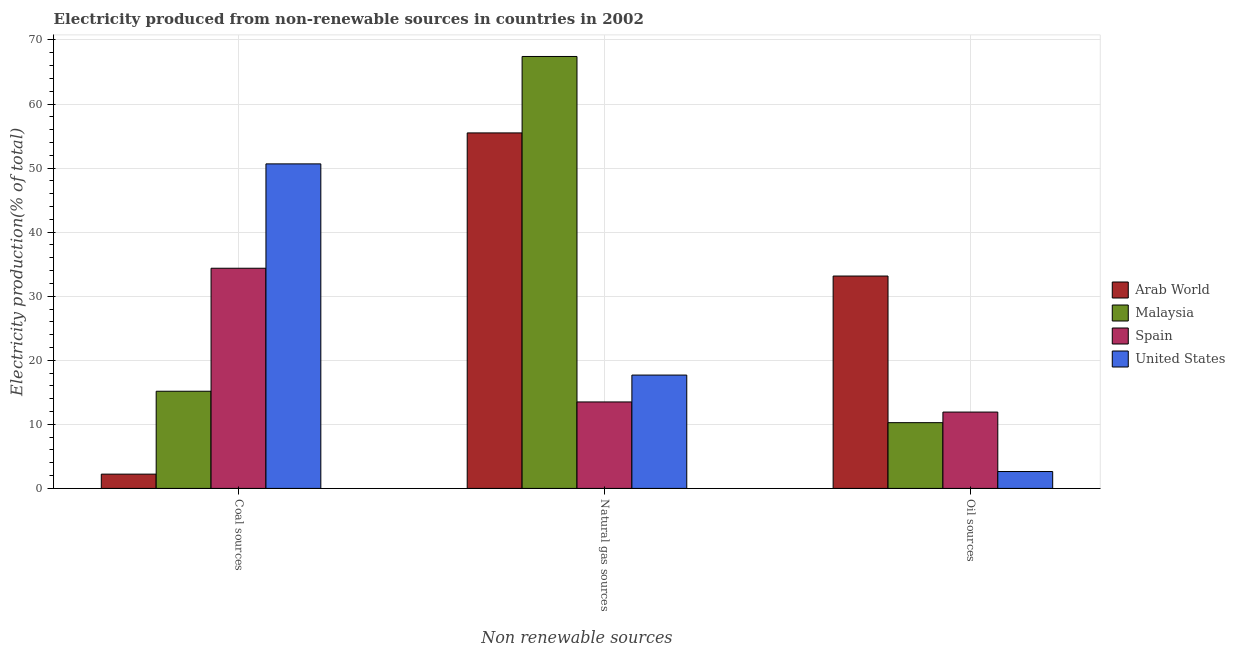How many groups of bars are there?
Your response must be concise. 3. Are the number of bars per tick equal to the number of legend labels?
Give a very brief answer. Yes. Are the number of bars on each tick of the X-axis equal?
Your answer should be compact. Yes. How many bars are there on the 2nd tick from the right?
Your response must be concise. 4. What is the label of the 3rd group of bars from the left?
Your response must be concise. Oil sources. What is the percentage of electricity produced by natural gas in Arab World?
Your response must be concise. 55.49. Across all countries, what is the maximum percentage of electricity produced by oil sources?
Your answer should be compact. 33.15. Across all countries, what is the minimum percentage of electricity produced by natural gas?
Ensure brevity in your answer.  13.5. In which country was the percentage of electricity produced by natural gas maximum?
Give a very brief answer. Malaysia. In which country was the percentage of electricity produced by coal minimum?
Offer a terse response. Arab World. What is the total percentage of electricity produced by oil sources in the graph?
Your response must be concise. 57.97. What is the difference between the percentage of electricity produced by coal in Spain and that in Arab World?
Give a very brief answer. 32.14. What is the difference between the percentage of electricity produced by oil sources in United States and the percentage of electricity produced by natural gas in Spain?
Make the answer very short. -10.86. What is the average percentage of electricity produced by oil sources per country?
Your answer should be compact. 14.49. What is the difference between the percentage of electricity produced by coal and percentage of electricity produced by natural gas in Spain?
Offer a very short reply. 20.87. In how many countries, is the percentage of electricity produced by oil sources greater than 16 %?
Your answer should be very brief. 1. What is the ratio of the percentage of electricity produced by natural gas in Spain to that in United States?
Your response must be concise. 0.76. Is the percentage of electricity produced by coal in Arab World less than that in Spain?
Provide a succinct answer. Yes. What is the difference between the highest and the second highest percentage of electricity produced by coal?
Your response must be concise. 16.29. What is the difference between the highest and the lowest percentage of electricity produced by coal?
Ensure brevity in your answer.  48.43. What does the 4th bar from the right in Oil sources represents?
Offer a terse response. Arab World. Is it the case that in every country, the sum of the percentage of electricity produced by coal and percentage of electricity produced by natural gas is greater than the percentage of electricity produced by oil sources?
Offer a very short reply. Yes. Are all the bars in the graph horizontal?
Provide a succinct answer. No. What is the difference between two consecutive major ticks on the Y-axis?
Your answer should be very brief. 10. Does the graph contain any zero values?
Your answer should be compact. No. Does the graph contain grids?
Offer a very short reply. Yes. How many legend labels are there?
Offer a terse response. 4. How are the legend labels stacked?
Your answer should be compact. Vertical. What is the title of the graph?
Ensure brevity in your answer.  Electricity produced from non-renewable sources in countries in 2002. Does "Swaziland" appear as one of the legend labels in the graph?
Make the answer very short. No. What is the label or title of the X-axis?
Your answer should be compact. Non renewable sources. What is the label or title of the Y-axis?
Give a very brief answer. Electricity production(% of total). What is the Electricity production(% of total) in Arab World in Coal sources?
Your answer should be very brief. 2.23. What is the Electricity production(% of total) of Malaysia in Coal sources?
Provide a short and direct response. 15.17. What is the Electricity production(% of total) in Spain in Coal sources?
Your response must be concise. 34.37. What is the Electricity production(% of total) of United States in Coal sources?
Give a very brief answer. 50.66. What is the Electricity production(% of total) of Arab World in Natural gas sources?
Ensure brevity in your answer.  55.49. What is the Electricity production(% of total) in Malaysia in Natural gas sources?
Your answer should be compact. 67.42. What is the Electricity production(% of total) in Spain in Natural gas sources?
Keep it short and to the point. 13.5. What is the Electricity production(% of total) of United States in Natural gas sources?
Ensure brevity in your answer.  17.69. What is the Electricity production(% of total) in Arab World in Oil sources?
Your answer should be compact. 33.15. What is the Electricity production(% of total) in Malaysia in Oil sources?
Give a very brief answer. 10.26. What is the Electricity production(% of total) of Spain in Oil sources?
Offer a terse response. 11.92. What is the Electricity production(% of total) of United States in Oil sources?
Give a very brief answer. 2.64. Across all Non renewable sources, what is the maximum Electricity production(% of total) of Arab World?
Provide a succinct answer. 55.49. Across all Non renewable sources, what is the maximum Electricity production(% of total) in Malaysia?
Offer a terse response. 67.42. Across all Non renewable sources, what is the maximum Electricity production(% of total) in Spain?
Keep it short and to the point. 34.37. Across all Non renewable sources, what is the maximum Electricity production(% of total) of United States?
Your answer should be very brief. 50.66. Across all Non renewable sources, what is the minimum Electricity production(% of total) of Arab World?
Provide a succinct answer. 2.23. Across all Non renewable sources, what is the minimum Electricity production(% of total) of Malaysia?
Give a very brief answer. 10.26. Across all Non renewable sources, what is the minimum Electricity production(% of total) in Spain?
Provide a short and direct response. 11.92. Across all Non renewable sources, what is the minimum Electricity production(% of total) in United States?
Provide a succinct answer. 2.64. What is the total Electricity production(% of total) of Arab World in the graph?
Ensure brevity in your answer.  90.87. What is the total Electricity production(% of total) of Malaysia in the graph?
Your answer should be very brief. 92.86. What is the total Electricity production(% of total) in Spain in the graph?
Provide a succinct answer. 59.79. What is the total Electricity production(% of total) in United States in the graph?
Provide a short and direct response. 70.99. What is the difference between the Electricity production(% of total) in Arab World in Coal sources and that in Natural gas sources?
Keep it short and to the point. -53.26. What is the difference between the Electricity production(% of total) in Malaysia in Coal sources and that in Natural gas sources?
Offer a very short reply. -52.26. What is the difference between the Electricity production(% of total) of Spain in Coal sources and that in Natural gas sources?
Give a very brief answer. 20.87. What is the difference between the Electricity production(% of total) of United States in Coal sources and that in Natural gas sources?
Your answer should be very brief. 32.96. What is the difference between the Electricity production(% of total) of Arab World in Coal sources and that in Oil sources?
Make the answer very short. -30.92. What is the difference between the Electricity production(% of total) in Malaysia in Coal sources and that in Oil sources?
Make the answer very short. 4.91. What is the difference between the Electricity production(% of total) of Spain in Coal sources and that in Oil sources?
Your answer should be compact. 22.45. What is the difference between the Electricity production(% of total) in United States in Coal sources and that in Oil sources?
Offer a very short reply. 48.02. What is the difference between the Electricity production(% of total) of Arab World in Natural gas sources and that in Oil sources?
Offer a terse response. 22.34. What is the difference between the Electricity production(% of total) in Malaysia in Natural gas sources and that in Oil sources?
Offer a very short reply. 57.16. What is the difference between the Electricity production(% of total) in Spain in Natural gas sources and that in Oil sources?
Ensure brevity in your answer.  1.58. What is the difference between the Electricity production(% of total) of United States in Natural gas sources and that in Oil sources?
Give a very brief answer. 15.06. What is the difference between the Electricity production(% of total) in Arab World in Coal sources and the Electricity production(% of total) in Malaysia in Natural gas sources?
Make the answer very short. -65.19. What is the difference between the Electricity production(% of total) of Arab World in Coal sources and the Electricity production(% of total) of Spain in Natural gas sources?
Ensure brevity in your answer.  -11.27. What is the difference between the Electricity production(% of total) in Arab World in Coal sources and the Electricity production(% of total) in United States in Natural gas sources?
Make the answer very short. -15.46. What is the difference between the Electricity production(% of total) of Malaysia in Coal sources and the Electricity production(% of total) of Spain in Natural gas sources?
Your answer should be very brief. 1.67. What is the difference between the Electricity production(% of total) of Malaysia in Coal sources and the Electricity production(% of total) of United States in Natural gas sources?
Give a very brief answer. -2.53. What is the difference between the Electricity production(% of total) of Spain in Coal sources and the Electricity production(% of total) of United States in Natural gas sources?
Your answer should be compact. 16.67. What is the difference between the Electricity production(% of total) of Arab World in Coal sources and the Electricity production(% of total) of Malaysia in Oil sources?
Your answer should be very brief. -8.03. What is the difference between the Electricity production(% of total) of Arab World in Coal sources and the Electricity production(% of total) of Spain in Oil sources?
Your response must be concise. -9.69. What is the difference between the Electricity production(% of total) of Arab World in Coal sources and the Electricity production(% of total) of United States in Oil sources?
Offer a very short reply. -0.41. What is the difference between the Electricity production(% of total) of Malaysia in Coal sources and the Electricity production(% of total) of United States in Oil sources?
Keep it short and to the point. 12.53. What is the difference between the Electricity production(% of total) in Spain in Coal sources and the Electricity production(% of total) in United States in Oil sources?
Give a very brief answer. 31.73. What is the difference between the Electricity production(% of total) in Arab World in Natural gas sources and the Electricity production(% of total) in Malaysia in Oil sources?
Offer a terse response. 45.23. What is the difference between the Electricity production(% of total) in Arab World in Natural gas sources and the Electricity production(% of total) in Spain in Oil sources?
Your answer should be compact. 43.57. What is the difference between the Electricity production(% of total) in Arab World in Natural gas sources and the Electricity production(% of total) in United States in Oil sources?
Give a very brief answer. 52.86. What is the difference between the Electricity production(% of total) of Malaysia in Natural gas sources and the Electricity production(% of total) of Spain in Oil sources?
Give a very brief answer. 55.51. What is the difference between the Electricity production(% of total) of Malaysia in Natural gas sources and the Electricity production(% of total) of United States in Oil sources?
Your answer should be compact. 64.79. What is the difference between the Electricity production(% of total) of Spain in Natural gas sources and the Electricity production(% of total) of United States in Oil sources?
Ensure brevity in your answer.  10.86. What is the average Electricity production(% of total) in Arab World per Non renewable sources?
Make the answer very short. 30.29. What is the average Electricity production(% of total) in Malaysia per Non renewable sources?
Offer a very short reply. 30.95. What is the average Electricity production(% of total) of Spain per Non renewable sources?
Offer a very short reply. 19.93. What is the average Electricity production(% of total) in United States per Non renewable sources?
Offer a very short reply. 23.66. What is the difference between the Electricity production(% of total) of Arab World and Electricity production(% of total) of Malaysia in Coal sources?
Provide a succinct answer. -12.94. What is the difference between the Electricity production(% of total) of Arab World and Electricity production(% of total) of Spain in Coal sources?
Make the answer very short. -32.14. What is the difference between the Electricity production(% of total) in Arab World and Electricity production(% of total) in United States in Coal sources?
Your answer should be compact. -48.43. What is the difference between the Electricity production(% of total) in Malaysia and Electricity production(% of total) in Spain in Coal sources?
Provide a short and direct response. -19.2. What is the difference between the Electricity production(% of total) of Malaysia and Electricity production(% of total) of United States in Coal sources?
Give a very brief answer. -35.49. What is the difference between the Electricity production(% of total) of Spain and Electricity production(% of total) of United States in Coal sources?
Give a very brief answer. -16.29. What is the difference between the Electricity production(% of total) in Arab World and Electricity production(% of total) in Malaysia in Natural gas sources?
Provide a short and direct response. -11.93. What is the difference between the Electricity production(% of total) in Arab World and Electricity production(% of total) in Spain in Natural gas sources?
Your answer should be very brief. 41.99. What is the difference between the Electricity production(% of total) in Arab World and Electricity production(% of total) in United States in Natural gas sources?
Provide a succinct answer. 37.8. What is the difference between the Electricity production(% of total) in Malaysia and Electricity production(% of total) in Spain in Natural gas sources?
Your answer should be very brief. 53.93. What is the difference between the Electricity production(% of total) of Malaysia and Electricity production(% of total) of United States in Natural gas sources?
Your response must be concise. 49.73. What is the difference between the Electricity production(% of total) in Spain and Electricity production(% of total) in United States in Natural gas sources?
Provide a succinct answer. -4.2. What is the difference between the Electricity production(% of total) of Arab World and Electricity production(% of total) of Malaysia in Oil sources?
Ensure brevity in your answer.  22.89. What is the difference between the Electricity production(% of total) of Arab World and Electricity production(% of total) of Spain in Oil sources?
Offer a very short reply. 21.23. What is the difference between the Electricity production(% of total) of Arab World and Electricity production(% of total) of United States in Oil sources?
Your answer should be very brief. 30.52. What is the difference between the Electricity production(% of total) in Malaysia and Electricity production(% of total) in Spain in Oil sources?
Keep it short and to the point. -1.66. What is the difference between the Electricity production(% of total) in Malaysia and Electricity production(% of total) in United States in Oil sources?
Provide a succinct answer. 7.63. What is the difference between the Electricity production(% of total) in Spain and Electricity production(% of total) in United States in Oil sources?
Ensure brevity in your answer.  9.28. What is the ratio of the Electricity production(% of total) in Arab World in Coal sources to that in Natural gas sources?
Keep it short and to the point. 0.04. What is the ratio of the Electricity production(% of total) in Malaysia in Coal sources to that in Natural gas sources?
Keep it short and to the point. 0.23. What is the ratio of the Electricity production(% of total) in Spain in Coal sources to that in Natural gas sources?
Make the answer very short. 2.55. What is the ratio of the Electricity production(% of total) of United States in Coal sources to that in Natural gas sources?
Provide a succinct answer. 2.86. What is the ratio of the Electricity production(% of total) of Arab World in Coal sources to that in Oil sources?
Offer a terse response. 0.07. What is the ratio of the Electricity production(% of total) in Malaysia in Coal sources to that in Oil sources?
Your answer should be very brief. 1.48. What is the ratio of the Electricity production(% of total) of Spain in Coal sources to that in Oil sources?
Ensure brevity in your answer.  2.88. What is the ratio of the Electricity production(% of total) of United States in Coal sources to that in Oil sources?
Your answer should be compact. 19.22. What is the ratio of the Electricity production(% of total) in Arab World in Natural gas sources to that in Oil sources?
Give a very brief answer. 1.67. What is the ratio of the Electricity production(% of total) in Malaysia in Natural gas sources to that in Oil sources?
Give a very brief answer. 6.57. What is the ratio of the Electricity production(% of total) in Spain in Natural gas sources to that in Oil sources?
Provide a succinct answer. 1.13. What is the ratio of the Electricity production(% of total) in United States in Natural gas sources to that in Oil sources?
Your answer should be compact. 6.71. What is the difference between the highest and the second highest Electricity production(% of total) in Arab World?
Provide a short and direct response. 22.34. What is the difference between the highest and the second highest Electricity production(% of total) in Malaysia?
Your answer should be very brief. 52.26. What is the difference between the highest and the second highest Electricity production(% of total) of Spain?
Your answer should be very brief. 20.87. What is the difference between the highest and the second highest Electricity production(% of total) of United States?
Your response must be concise. 32.96. What is the difference between the highest and the lowest Electricity production(% of total) in Arab World?
Offer a terse response. 53.26. What is the difference between the highest and the lowest Electricity production(% of total) of Malaysia?
Give a very brief answer. 57.16. What is the difference between the highest and the lowest Electricity production(% of total) of Spain?
Give a very brief answer. 22.45. What is the difference between the highest and the lowest Electricity production(% of total) of United States?
Your answer should be very brief. 48.02. 